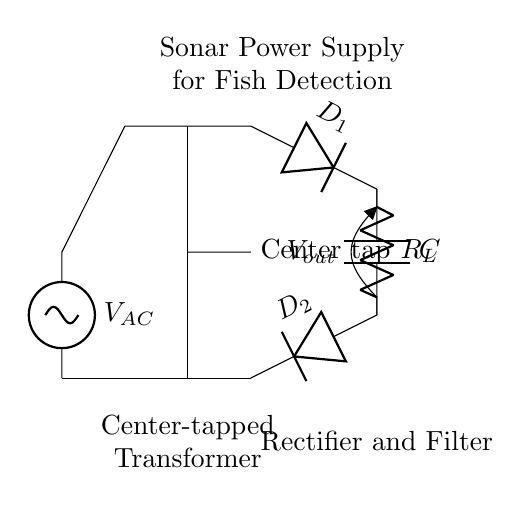What type of transformer is used in this circuit? The circuit uses a center-tapped transformer, which is indicated by the label and the specific layout showing a tap at the center of the coil.
Answer: Center-tapped transformer How many diodes are in the rectifier section? The rectifier section shows two distinct diodes labeled D1 and D2, indicating that there are two diodes utilized in this circuit.
Answer: Two What is the function of the capacitor in this circuit? The capacitor is used to filter the output voltage, smoothing the rectified AC signal to provide a more stable DC voltage output.
Answer: Filter What is the purpose of the load resistor R_L? The load resistor R_L serves to represent the actual load that the sonar device will draw current from when it is powered by the circuit.
Answer: Power load What is the output voltage type of this rectifier? The design indicates the output voltage is a DC voltage as the diodes convert the AC input from the transformer to a unidirectional flow of current, typical for rectifiers.
Answer: DC voltage How does the center-tapped transformer contribute to the rectification process? The center-tapped transformer provides two equal voltages from the center tap, allowing both diodes to conduct in separate half-cycles, effectively converting AC to DC.
Answer: AC to DC conversion 